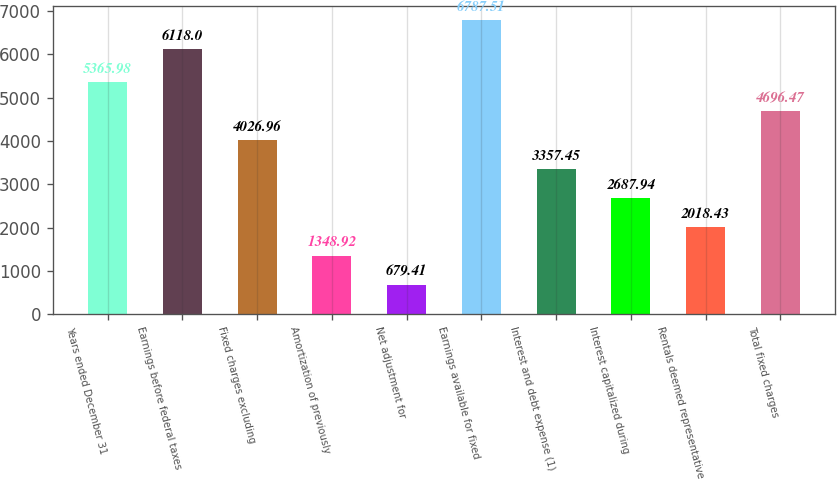Convert chart to OTSL. <chart><loc_0><loc_0><loc_500><loc_500><bar_chart><fcel>Years ended December 31<fcel>Earnings before federal taxes<fcel>Fixed charges excluding<fcel>Amortization of previously<fcel>Net adjustment for<fcel>Earnings available for fixed<fcel>Interest and debt expense (1)<fcel>Interest capitalized during<fcel>Rentals deemed representative<fcel>Total fixed charges<nl><fcel>5365.98<fcel>6118<fcel>4026.96<fcel>1348.92<fcel>679.41<fcel>6787.51<fcel>3357.45<fcel>2687.94<fcel>2018.43<fcel>4696.47<nl></chart> 